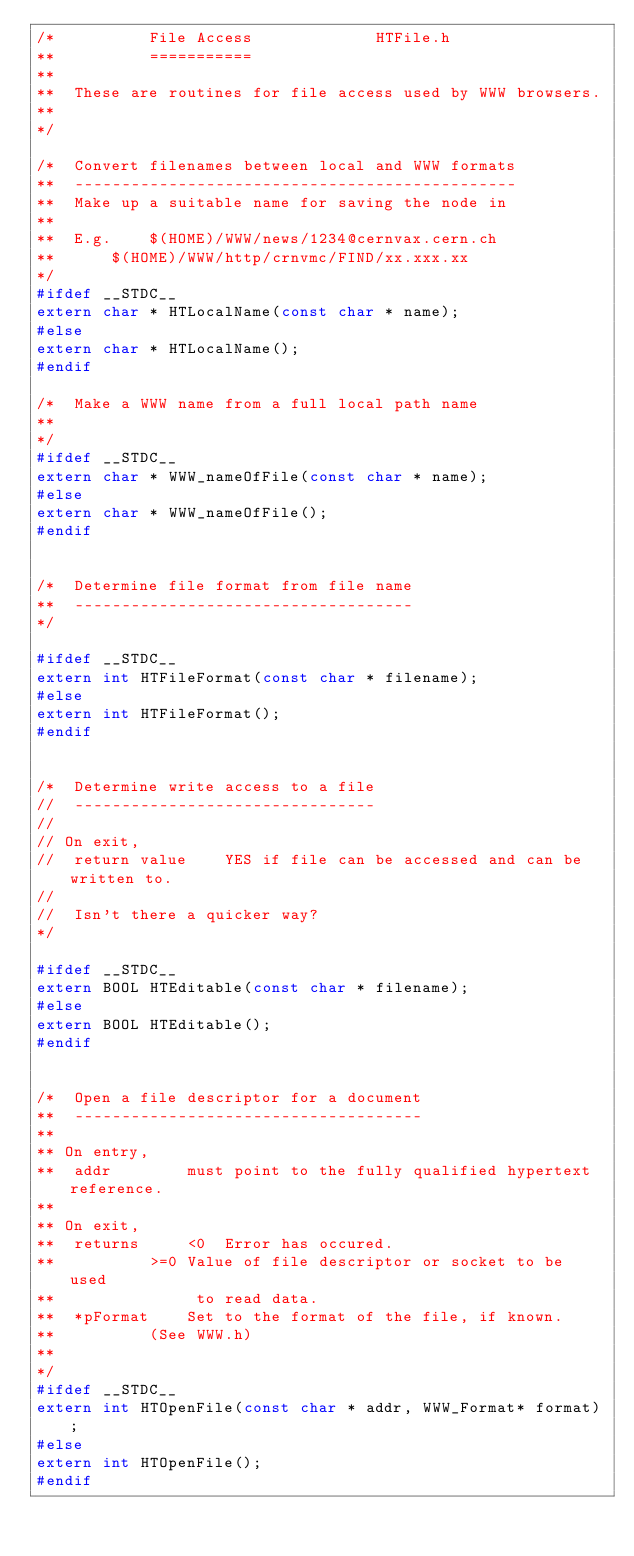<code> <loc_0><loc_0><loc_500><loc_500><_C_>/*			File Access				HTFile.h
**			===========
**
**	These are routines for file access used by WWW browsers.
**
*/

/*	Convert filenames between local and WWW formats
**	-----------------------------------------------
**	Make up a suitable name for saving the node in
**
**	E.g.	$(HOME)/WWW/news/1234@cernvax.cern.ch
**		$(HOME)/WWW/http/crnvmc/FIND/xx.xxx.xx
*/
#ifdef __STDC__
extern char * HTLocalName(const char * name);
#else
extern char * HTLocalName();
#endif

/*	Make a WWW name from a full local path name
**
*/
#ifdef __STDC__
extern char * WWW_nameOfFile(const char * name);
#else
extern char * WWW_nameOfFile();
#endif


/*	Determine file format from file name
**	------------------------------------
*/

#ifdef __STDC__
extern int HTFileFormat(const char * filename);
#else
extern int HTFileFormat();
#endif	


/*	Determine write access to a file
//	--------------------------------
//
// On exit,
//	return value	YES if file can be accessed and can be written to.
//
//	Isn't there a quicker way?
*/

#ifdef __STDC__
extern BOOL HTEditable(const char * filename);
#else
extern BOOL HTEditable();
#endif


/*	Open a file descriptor for a document
**	-------------------------------------
**
** On entry,
**	addr		must point to the fully qualified hypertext reference.
**
** On exit,
**	returns		<0	Error has occured.
**			>=0	Value of file descriptor or socket to be used
**				 to read data.
**	*pFormat	Set to the format of the file, if known.
**			(See WWW.h)
**
*/
#ifdef __STDC__
extern int HTOpenFile(const char * addr, WWW_Format* format);
#else
extern int HTOpenFile();
#endif

</code> 